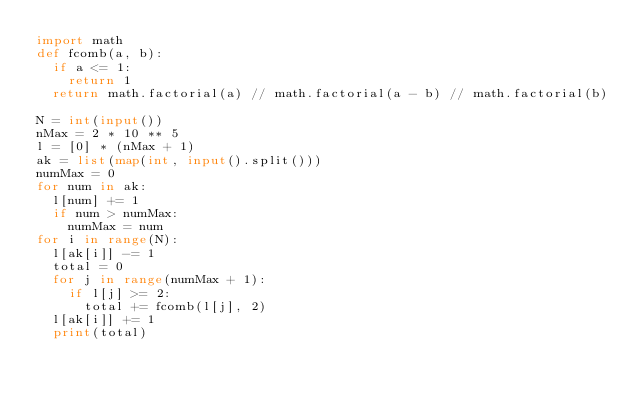Convert code to text. <code><loc_0><loc_0><loc_500><loc_500><_Python_>import math
def fcomb(a, b):
  if a <= 1:
    return 1
  return math.factorial(a) // math.factorial(a - b) // math.factorial(b)

N = int(input())
nMax = 2 * 10 ** 5
l = [0] * (nMax + 1)
ak = list(map(int, input().split()))
numMax = 0
for num in ak:
  l[num] += 1
  if num > numMax:
    numMax = num
for i in range(N):
  l[ak[i]] -= 1
  total = 0
  for j in range(numMax + 1):
    if l[j] >= 2:
      total += fcomb(l[j], 2)
  l[ak[i]] += 1
  print(total)
</code> 